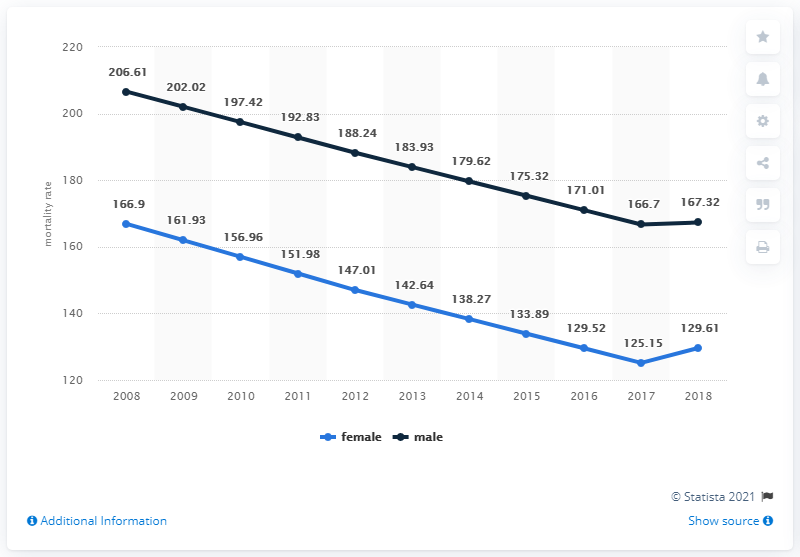Highlight a few significant elements in this photo. In 2018, the mortality rate for men in Nepal was 167.32 per 1,000 people. According to data from 2018, the mortality rate for women in Nepal was 129.61 per 100,000 live births. 